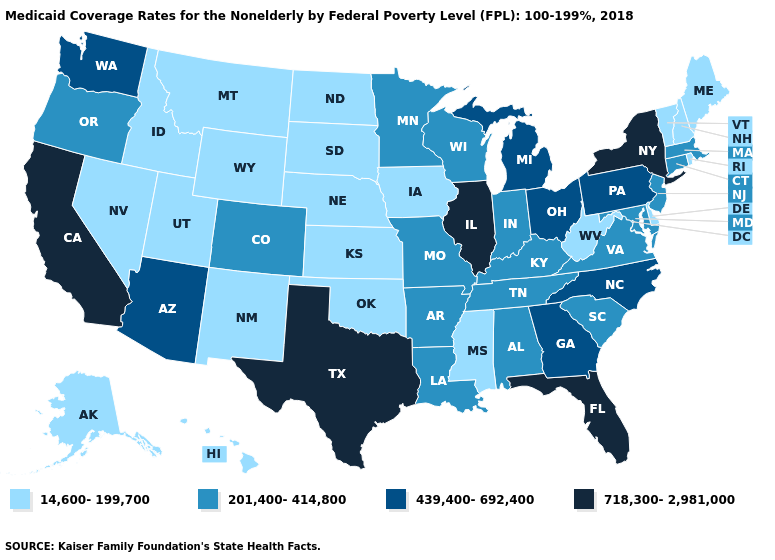Which states hav the highest value in the Northeast?
Be succinct. New York. Does Massachusetts have the lowest value in the Northeast?
Be succinct. No. What is the highest value in the MidWest ?
Concise answer only. 718,300-2,981,000. Which states have the highest value in the USA?
Short answer required. California, Florida, Illinois, New York, Texas. What is the highest value in the USA?
Quick response, please. 718,300-2,981,000. How many symbols are there in the legend?
Give a very brief answer. 4. What is the value of Maine?
Answer briefly. 14,600-199,700. What is the value of Utah?
Answer briefly. 14,600-199,700. What is the value of Hawaii?
Concise answer only. 14,600-199,700. Which states hav the highest value in the MidWest?
Write a very short answer. Illinois. What is the lowest value in the USA?
Short answer required. 14,600-199,700. Does the map have missing data?
Concise answer only. No. Name the states that have a value in the range 718,300-2,981,000?
Write a very short answer. California, Florida, Illinois, New York, Texas. Among the states that border Nevada , does California have the lowest value?
Keep it brief. No. Among the states that border Illinois , which have the lowest value?
Keep it brief. Iowa. 